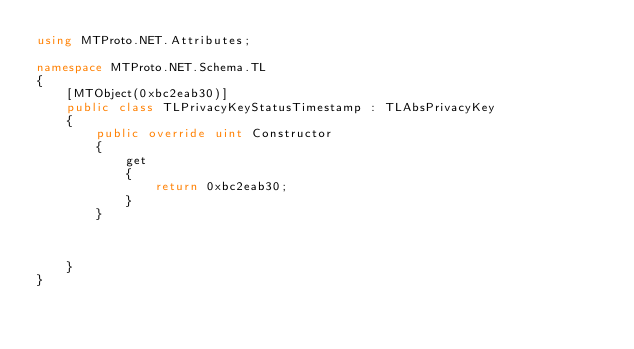<code> <loc_0><loc_0><loc_500><loc_500><_C#_>using MTProto.NET.Attributes;

namespace MTProto.NET.Schema.TL
{
    [MTObject(0xbc2eab30)]
    public class TLPrivacyKeyStatusTimestamp : TLAbsPrivacyKey
    {
        public override uint Constructor
        {
            get
            {
                return 0xbc2eab30;
            }
        }



    }
}
</code> 